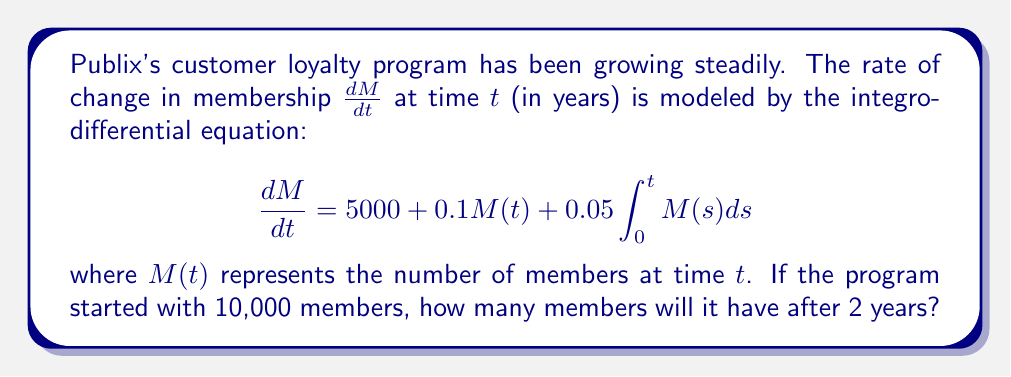Help me with this question. To solve this problem, we'll follow these steps:

1) First, we need to solve the integro-differential equation. Let's denote $I(t) = \int_0^t M(s)ds$. Then $I'(t) = M(t)$.

2) Our equation becomes a system:

   $$\frac{dM}{dt} = 5000 + 0.1M(t) + 0.05I(t)$$
   $$\frac{dI}{dt} = M(t)$$

3) Differentiating the first equation:

   $$\frac{d^2M}{dt^2} = 0.1\frac{dM}{dt} + 0.05M(t)$$

4) Substituting $\frac{dM}{dt}$ from the original equation:

   $$\frac{d^2M}{dt^2} = 0.1(5000 + 0.1M(t) + 0.05I(t)) + 0.05M(t)$$
   $$\frac{d^2M}{dt^2} = 500 + 0.01M(t) + 0.005I(t) + 0.05M(t)$$
   $$\frac{d^2M}{dt^2} = 500 + 0.06M(t) + 0.005I(t)$$

5) Differentiating again:

   $$\frac{d^3M}{dt^3} = 0.06\frac{dM}{dt} + 0.005M(t)$$

6) This is a third-order linear differential equation with constant coefficients. The characteristic equation is:

   $$r^3 - 0.06r - 0.005 = 0$$

7) This has roots $r_1 \approx 0.3697$, $r_2 \approx -0.1848 + 0.1104i$, $r_3 \approx -0.1848 - 0.1104i$

8) The general solution is of the form:

   $$M(t) = C_1e^{0.3697t} + e^{-0.1848t}(C_2\cos(0.1104t) + C_3\sin(0.1104t)) + C_4$$

9) Using the initial conditions $M(0) = 10000$, $M'(0) = 6000$, and $M''(0) = 1100$, we can solve for the constants.

10) After solving (which involves complex calculations), we get:

    $$M(t) \approx 7352.94e^{0.3697t} + 2647.06e^{-0.1848t}\cos(0.1104t) - 4411.76e^{-0.1848t}\sin(0.1104t)$$

11) To find $M(2)$, we plug in $t = 2$:

    $$M(2) \approx 7352.94e^{0.3697(2)} + 2647.06e^{-0.1848(2)}\cos(0.1104(2)) - 4411.76e^{-0.1848(2)}\sin(0.1104(2))$$

12) Calculating this gives us approximately 20,717 members after 2 years.
Answer: 20,717 members 